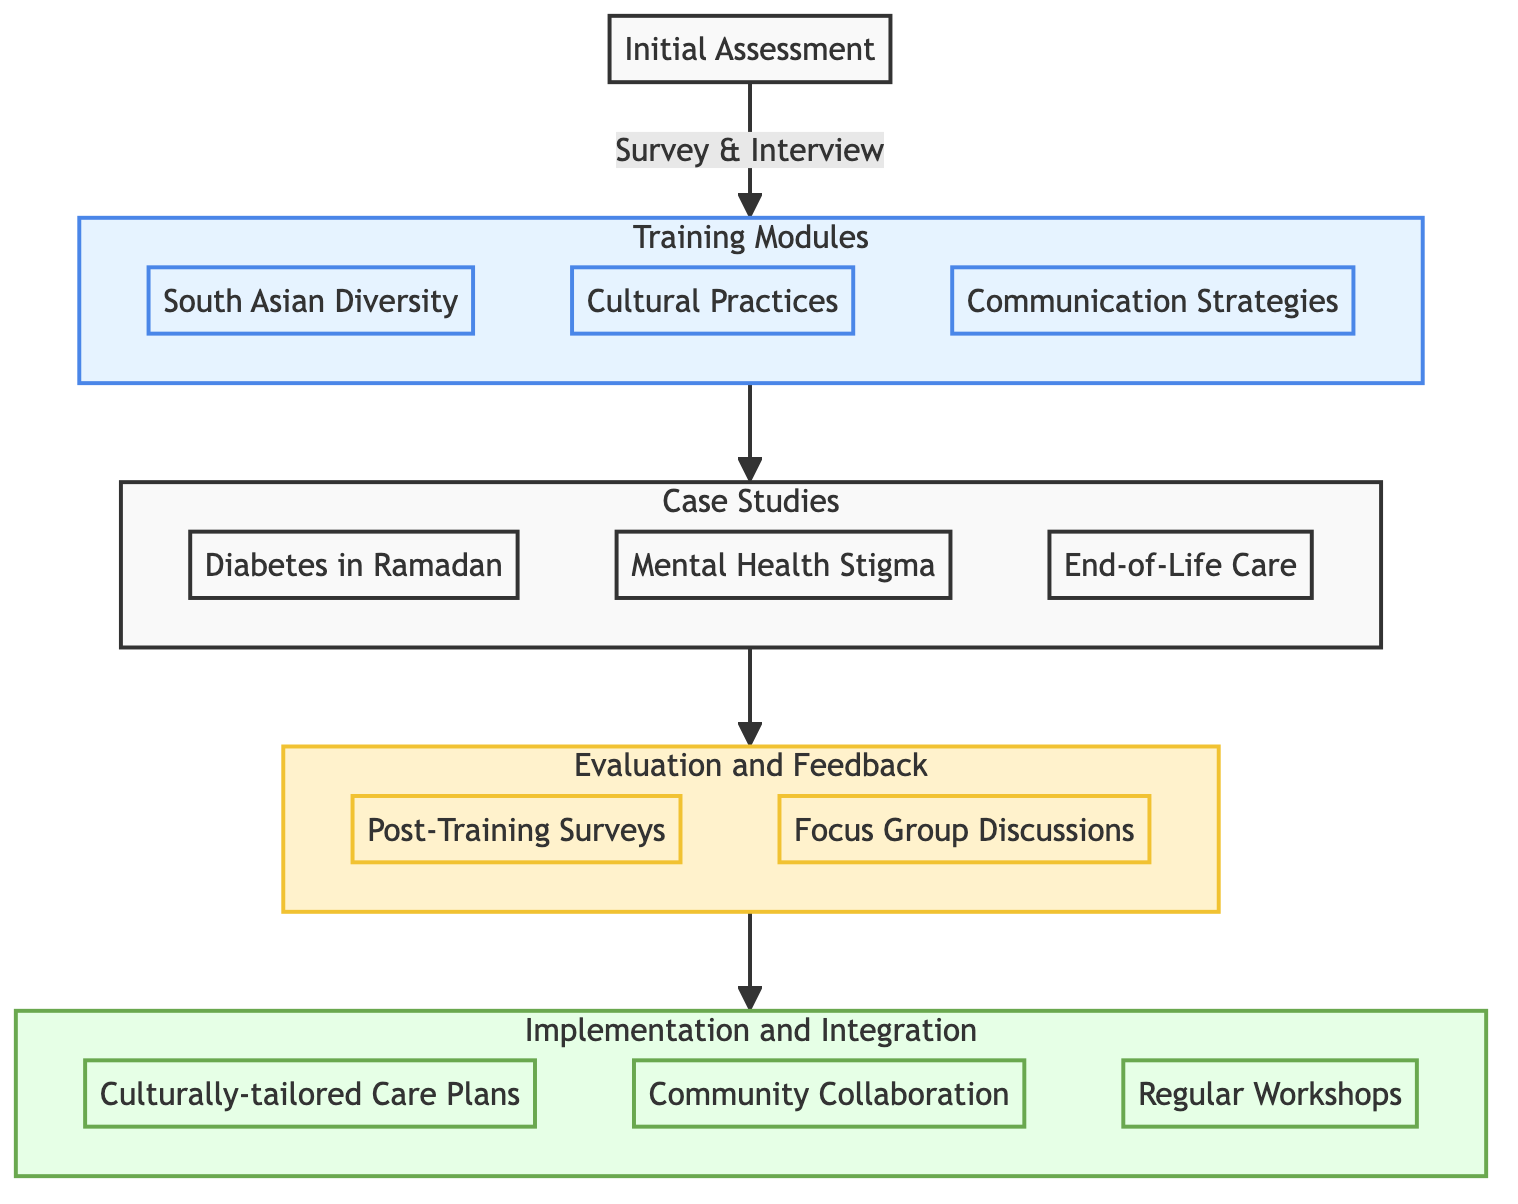What is the first step in the Clinical Pathway? The diagram shows that the first step is "Initial Assessment." This is clearly indicated as the starting point of the pathway before any other nodes.
Answer: Initial Assessment How many Training Modules are there? The diagram highlights three distinct modules under the Training Modules node: "Introduction to South Asian Ethnic and Religious Diversity," "Cultural Practices and Health Beliefs," and "Communication Strategies." Counting these gives a total of three.
Answer: 3 What follows after the Case Studies? The diagram flows from the Case Studies node directly to the Evaluation and Feedback node, indicating that Evaluation and Feedback is the next step after Case Studies.
Answer: Evaluation and Feedback Name one example of a Case Study. The diagram lists three specific case study examples under the Case Studies node, one of which is "Managing Diabetes in a Muslim Patient During Ramadan." You can select any one from these examples.
Answer: Managing Diabetes in a Muslim Patient During Ramadan What is a key step in the Implementation and Integration stage? Under the Implementation and Integration node, several key steps are listed, with "Developing Culturally-tailored Care Plans" being one of them. This step is mentioned directly in the diagram as part of this phase.
Answer: Developing Culturally-tailored Care Plans Which module addresses dietary restrictions? The module titled "Cultural Practices and Health Beliefs" specifically includes "Dietary Restrictions and Preferences" in its contents, clearly identifying it as the relevant training to learn about dietary concerns.
Answer: Cultural Practices and Health Beliefs What is the purpose of the post-training surveys? The diagram indicates that post-training surveys are conducted as part of the Evaluation and Feedback process, aimed at assessing the effectiveness of the training program and identifying areas for improvement.
Answer: Assess effectiveness How many key steps are in the Evaluation and Feedback stage? Upon examining the Evaluation and Feedback node, we find it lists two key steps: "Post-Training Surveys" and "Focus Group Discussions," leading to a total of two steps in this stage.
Answer: 2 Which Training Module focuses on communication strategies? The diagram clearly identifies "Communication Strategies" as one of the three training modules, pinpointing exactly where the module focusing on communication is located in the pathway.
Answer: Communication Strategies 